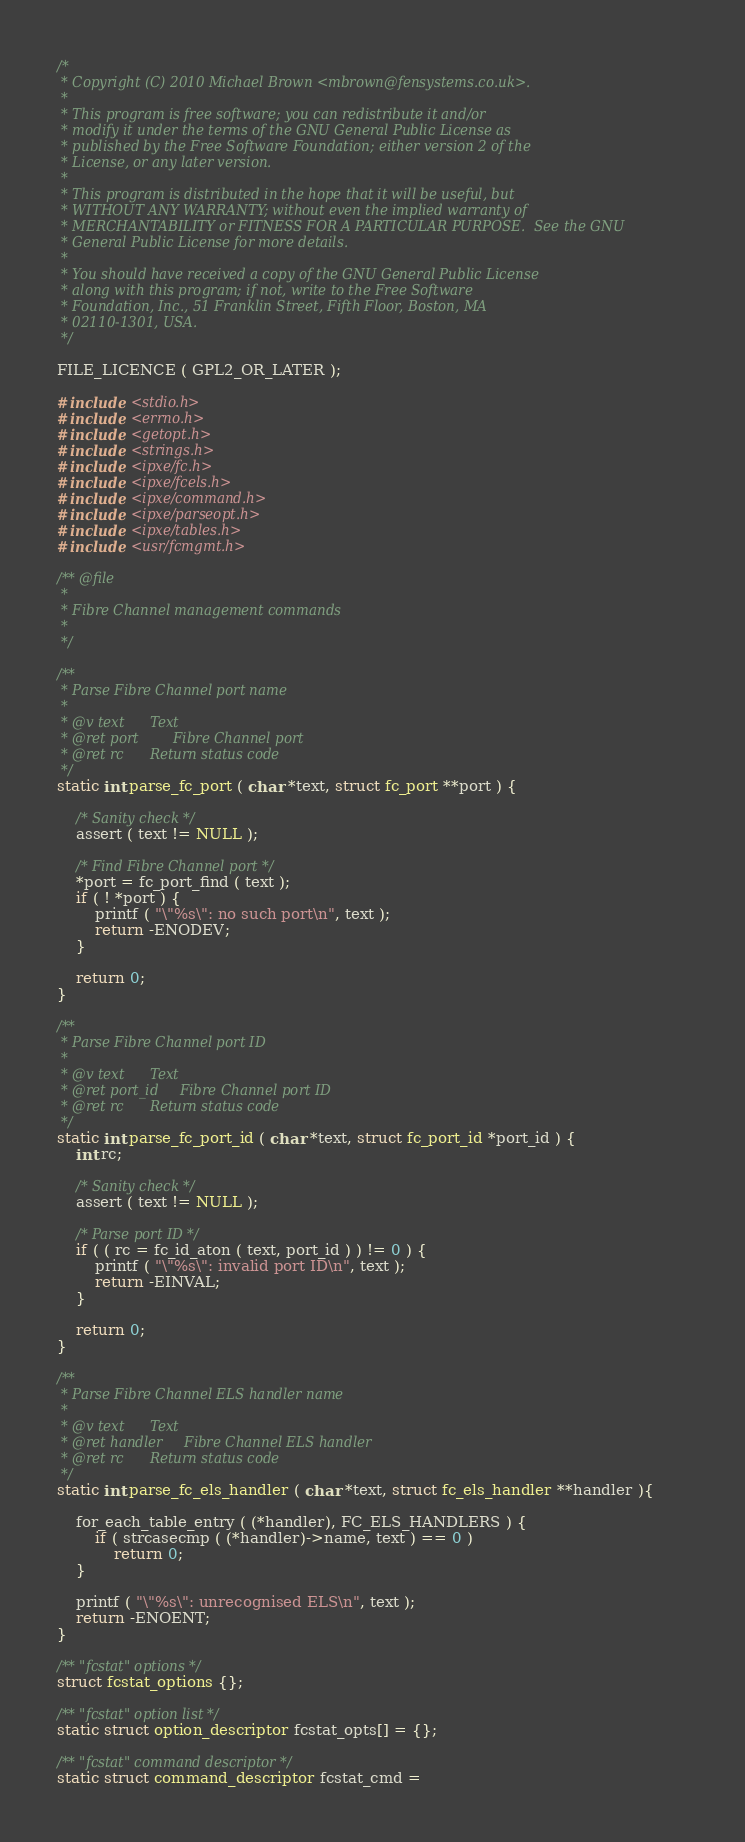<code> <loc_0><loc_0><loc_500><loc_500><_C_>/*
 * Copyright (C) 2010 Michael Brown <mbrown@fensystems.co.uk>.
 *
 * This program is free software; you can redistribute it and/or
 * modify it under the terms of the GNU General Public License as
 * published by the Free Software Foundation; either version 2 of the
 * License, or any later version.
 *
 * This program is distributed in the hope that it will be useful, but
 * WITHOUT ANY WARRANTY; without even the implied warranty of
 * MERCHANTABILITY or FITNESS FOR A PARTICULAR PURPOSE.  See the GNU
 * General Public License for more details.
 *
 * You should have received a copy of the GNU General Public License
 * along with this program; if not, write to the Free Software
 * Foundation, Inc., 51 Franklin Street, Fifth Floor, Boston, MA
 * 02110-1301, USA.
 */

FILE_LICENCE ( GPL2_OR_LATER );

#include <stdio.h>
#include <errno.h>
#include <getopt.h>
#include <strings.h>
#include <ipxe/fc.h>
#include <ipxe/fcels.h>
#include <ipxe/command.h>
#include <ipxe/parseopt.h>
#include <ipxe/tables.h>
#include <usr/fcmgmt.h>

/** @file
 *
 * Fibre Channel management commands
 *
 */

/**
 * Parse Fibre Channel port name
 *
 * @v text		Text
 * @ret port		Fibre Channel port
 * @ret rc		Return status code
 */
static int parse_fc_port ( char *text, struct fc_port **port ) {

	/* Sanity check */
	assert ( text != NULL );

	/* Find Fibre Channel port */
	*port = fc_port_find ( text );
	if ( ! *port ) {
		printf ( "\"%s\": no such port\n", text );
		return -ENODEV;
	}

	return 0;
}

/**
 * Parse Fibre Channel port ID
 *
 * @v text		Text
 * @ret port_id		Fibre Channel port ID
 * @ret rc		Return status code
 */
static int parse_fc_port_id ( char *text, struct fc_port_id *port_id ) {
	int rc;

	/* Sanity check */
	assert ( text != NULL );

	/* Parse port ID */
	if ( ( rc = fc_id_aton ( text, port_id ) ) != 0 ) {
		printf ( "\"%s\": invalid port ID\n", text );
		return -EINVAL;
	}

	return 0;
}

/**
 * Parse Fibre Channel ELS handler name
 *
 * @v text		Text
 * @ret handler		Fibre Channel ELS handler
 * @ret rc		Return status code
 */
static int parse_fc_els_handler ( char *text, struct fc_els_handler **handler ){

	for_each_table_entry ( (*handler), FC_ELS_HANDLERS ) {
		if ( strcasecmp ( (*handler)->name, text ) == 0 )
			return 0;
	}

	printf ( "\"%s\": unrecognised ELS\n", text );
	return -ENOENT;
}

/** "fcstat" options */
struct fcstat_options {};

/** "fcstat" option list */
static struct option_descriptor fcstat_opts[] = {};

/** "fcstat" command descriptor */
static struct command_descriptor fcstat_cmd =</code> 